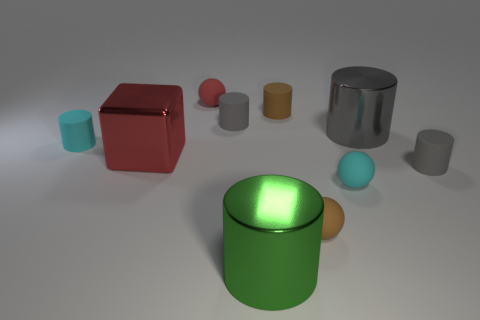What number of tiny gray things are the same shape as the tiny red object?
Make the answer very short. 0. There is a metallic object on the left side of the shiny thing in front of the tiny rubber cylinder that is in front of the small cyan matte cylinder; how big is it?
Offer a very short reply. Large. Is the number of large red objects on the right side of the small red ball greater than the number of blue shiny blocks?
Make the answer very short. No. Are any brown cylinders visible?
Your response must be concise. Yes. How many gray cylinders are the same size as the green metal cylinder?
Your answer should be compact. 1. Is the number of tiny red matte things on the right side of the tiny brown cylinder greater than the number of large metal cylinders left of the large red metallic thing?
Make the answer very short. No. What material is the gray object that is the same size as the red shiny block?
Ensure brevity in your answer.  Metal. What shape is the large gray object?
Offer a very short reply. Cylinder. What number of brown things are either small rubber objects or large shiny cylinders?
Provide a succinct answer. 2. What is the size of the green cylinder that is the same material as the cube?
Your answer should be compact. Large. 